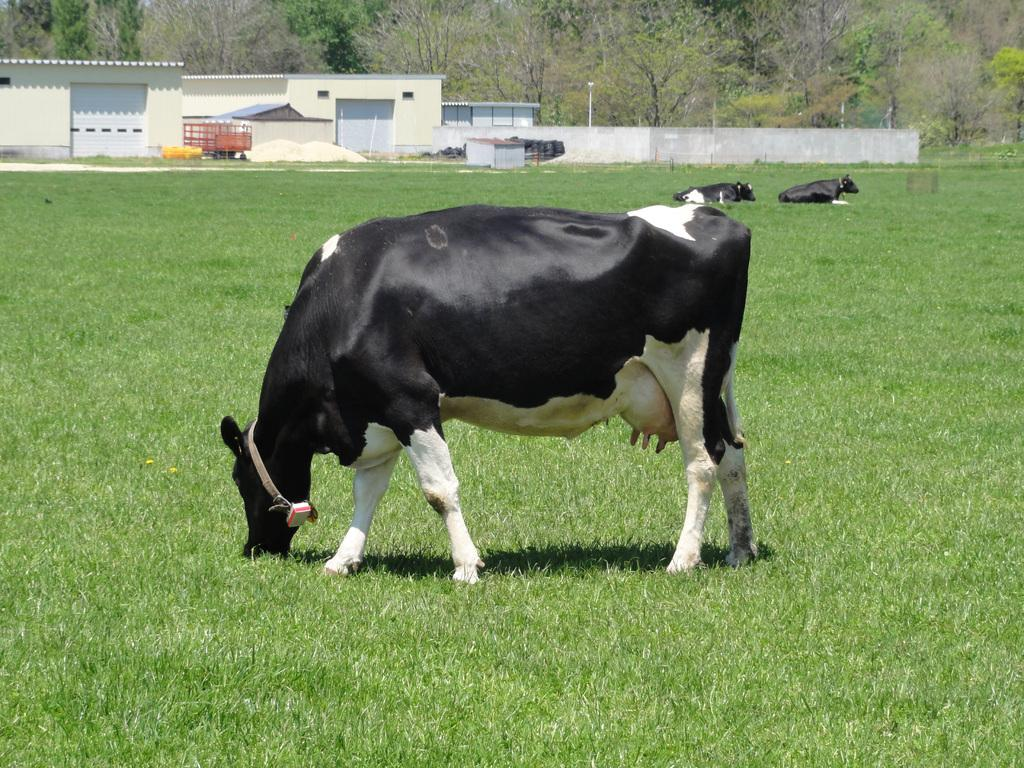What animals can be seen on the grass field in the image? There are cows on the grass field in the image. What type of structure is present in the image? There is a shed with shutters in the image. What material is used for the shed's frame? The shed has a metal frame. What is one of the architectural elements in the image? There is a wall in the image. What are the tall, thin objects in the image? There are poles in the image. What type of vegetation can be seen in the image? There is a group of trees in the image. What type of spoon can be seen in the image? There is no spoon present in the image. Can you describe the jellyfish floating in the air in the image? There are no jellyfish present in the image; it features cows on a grass field, a shed, a wall, poles, and a group of trees. 